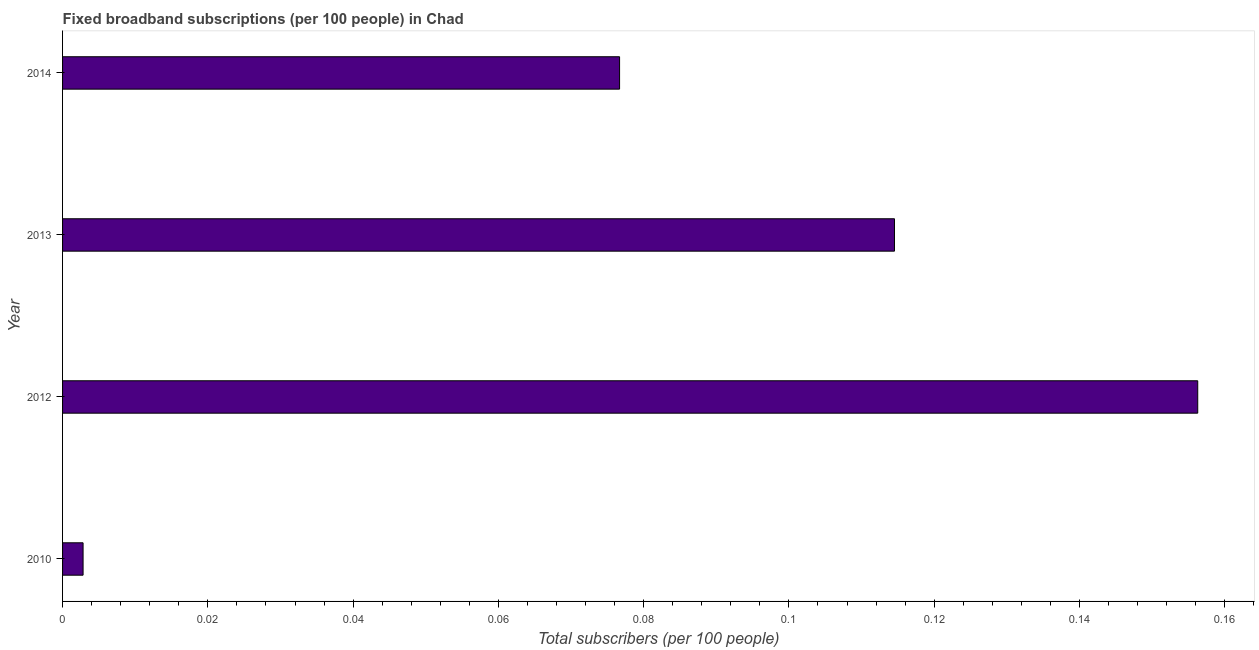What is the title of the graph?
Your answer should be compact. Fixed broadband subscriptions (per 100 people) in Chad. What is the label or title of the X-axis?
Keep it short and to the point. Total subscribers (per 100 people). What is the label or title of the Y-axis?
Ensure brevity in your answer.  Year. What is the total number of fixed broadband subscriptions in 2013?
Keep it short and to the point. 0.11. Across all years, what is the maximum total number of fixed broadband subscriptions?
Offer a terse response. 0.16. Across all years, what is the minimum total number of fixed broadband subscriptions?
Offer a very short reply. 0. In which year was the total number of fixed broadband subscriptions maximum?
Ensure brevity in your answer.  2012. In which year was the total number of fixed broadband subscriptions minimum?
Offer a very short reply. 2010. What is the sum of the total number of fixed broadband subscriptions?
Provide a succinct answer. 0.35. What is the difference between the total number of fixed broadband subscriptions in 2010 and 2012?
Your response must be concise. -0.15. What is the average total number of fixed broadband subscriptions per year?
Offer a very short reply. 0.09. What is the median total number of fixed broadband subscriptions?
Keep it short and to the point. 0.1. Do a majority of the years between 2014 and 2012 (inclusive) have total number of fixed broadband subscriptions greater than 0.144 ?
Provide a short and direct response. Yes. What is the ratio of the total number of fixed broadband subscriptions in 2010 to that in 2014?
Provide a short and direct response. 0.04. Is the difference between the total number of fixed broadband subscriptions in 2010 and 2013 greater than the difference between any two years?
Your answer should be very brief. No. What is the difference between the highest and the second highest total number of fixed broadband subscriptions?
Keep it short and to the point. 0.04. Is the sum of the total number of fixed broadband subscriptions in 2010 and 2014 greater than the maximum total number of fixed broadband subscriptions across all years?
Keep it short and to the point. No. What is the difference between the highest and the lowest total number of fixed broadband subscriptions?
Offer a very short reply. 0.15. How many years are there in the graph?
Provide a short and direct response. 4. What is the Total subscribers (per 100 people) of 2010?
Your answer should be very brief. 0. What is the Total subscribers (per 100 people) of 2012?
Make the answer very short. 0.16. What is the Total subscribers (per 100 people) of 2013?
Keep it short and to the point. 0.11. What is the Total subscribers (per 100 people) of 2014?
Make the answer very short. 0.08. What is the difference between the Total subscribers (per 100 people) in 2010 and 2012?
Your answer should be compact. -0.15. What is the difference between the Total subscribers (per 100 people) in 2010 and 2013?
Offer a terse response. -0.11. What is the difference between the Total subscribers (per 100 people) in 2010 and 2014?
Provide a succinct answer. -0.07. What is the difference between the Total subscribers (per 100 people) in 2012 and 2013?
Make the answer very short. 0.04. What is the difference between the Total subscribers (per 100 people) in 2012 and 2014?
Ensure brevity in your answer.  0.08. What is the difference between the Total subscribers (per 100 people) in 2013 and 2014?
Give a very brief answer. 0.04. What is the ratio of the Total subscribers (per 100 people) in 2010 to that in 2012?
Give a very brief answer. 0.02. What is the ratio of the Total subscribers (per 100 people) in 2010 to that in 2013?
Make the answer very short. 0.03. What is the ratio of the Total subscribers (per 100 people) in 2010 to that in 2014?
Make the answer very short. 0.04. What is the ratio of the Total subscribers (per 100 people) in 2012 to that in 2013?
Give a very brief answer. 1.36. What is the ratio of the Total subscribers (per 100 people) in 2012 to that in 2014?
Your response must be concise. 2.04. What is the ratio of the Total subscribers (per 100 people) in 2013 to that in 2014?
Ensure brevity in your answer.  1.49. 